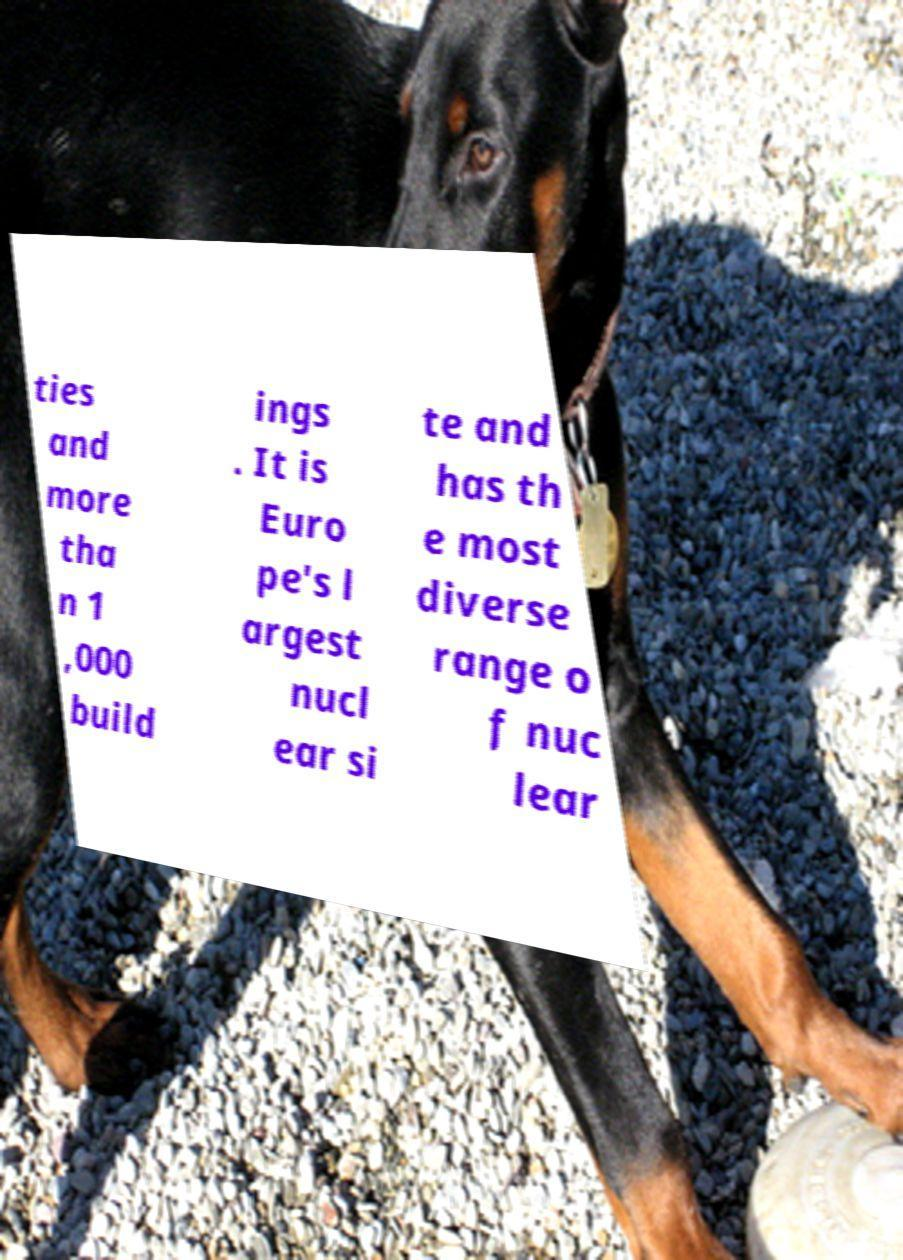There's text embedded in this image that I need extracted. Can you transcribe it verbatim? ties and more tha n 1 ,000 build ings . It is Euro pe's l argest nucl ear si te and has th e most diverse range o f nuc lear 